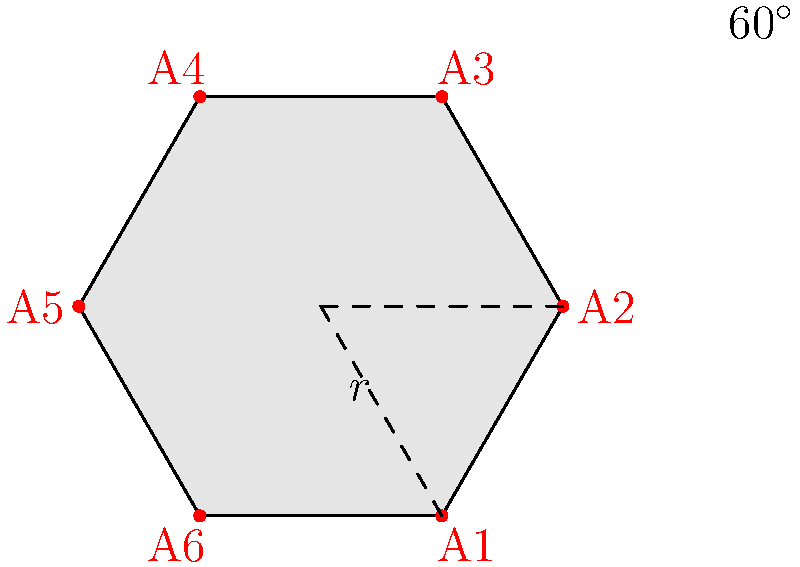In a new hexagonal user interface design for ad placements, the distance from the center to any vertex is $r$ units. If the effectiveness of an ad placement is directly proportional to its distance from the center, and the most effective placement (A1) has an effectiveness score of 100, what is the effectiveness score of the ad placement at A4? Round your answer to the nearest whole number. To solve this problem, we need to follow these steps:

1) First, we need to understand the geometry of a regular hexagon. The angle between any two adjacent vertices from the center is 60°.

2) The placement A1 is at a distance $r$ from the center and has an effectiveness score of 100. This establishes our baseline.

3) To find the distance of A4 from the center, we need to use trigonometry. A4 is opposite to A1 in the hexagon, so it forms a straight line with A1 through the center.

4) The distance from the center to A4 can be calculated using the cosine function:

   $$\text{distance to A4} = r \cos 180° = -r$$

5) The absolute distance is $r$, same as A1.

6) Since the effectiveness is directly proportional to the distance, and A4 is at the same distance as A1, it will have the same effectiveness score.

Therefore, the effectiveness score of A4 is also 100.
Answer: 100 